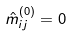Convert formula to latex. <formula><loc_0><loc_0><loc_500><loc_500>\hat { m } _ { i j } ^ { ( 0 ) } = 0</formula> 